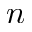<formula> <loc_0><loc_0><loc_500><loc_500>n</formula> 